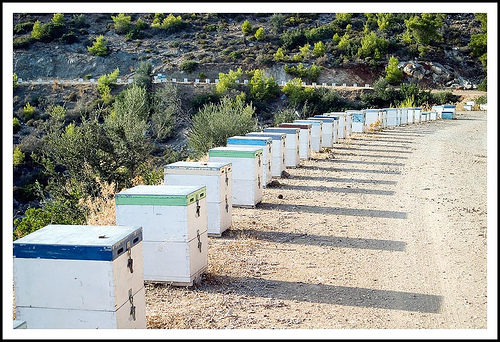<image>
Can you confirm if the blue box is on the green box? No. The blue box is not positioned on the green box. They may be near each other, but the blue box is not supported by or resting on top of the green box. 